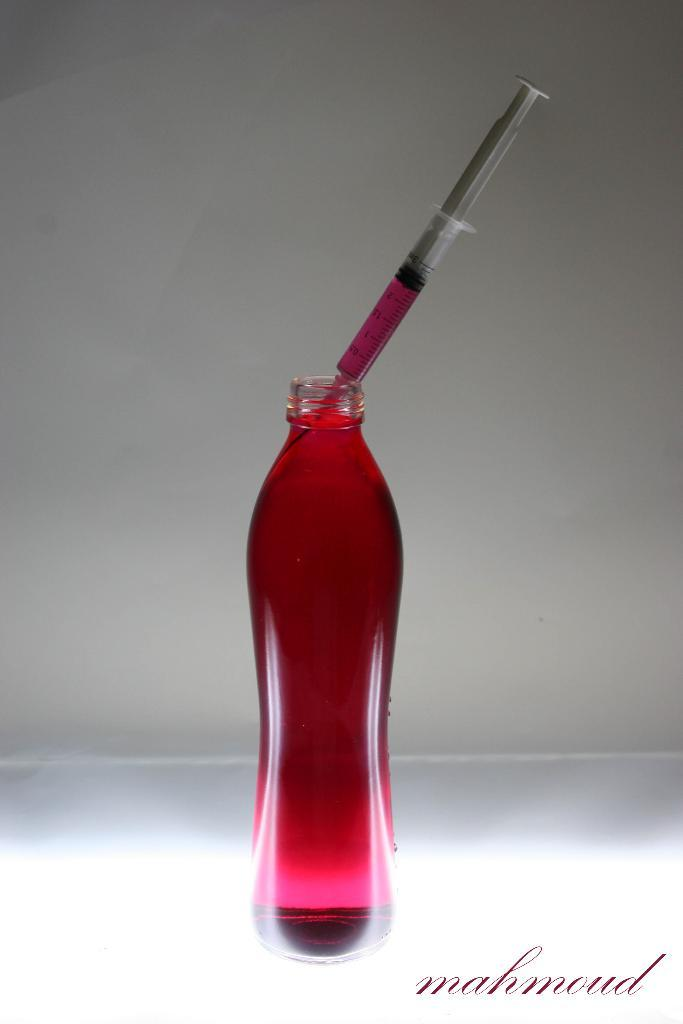What object is present in the image? There is a bottle in the image. What can be observed about the liquid inside the bottle? The liquid inside the bottle is pink. What is also present inside the bottle? There is an injection inside the bottle. How would you describe the nature of the image? The image appears to be a poster. How many ideas can be seen floating around the bottle in the image? There are no ideas present in the image; it features a bottle with pink liquid and an injection. 